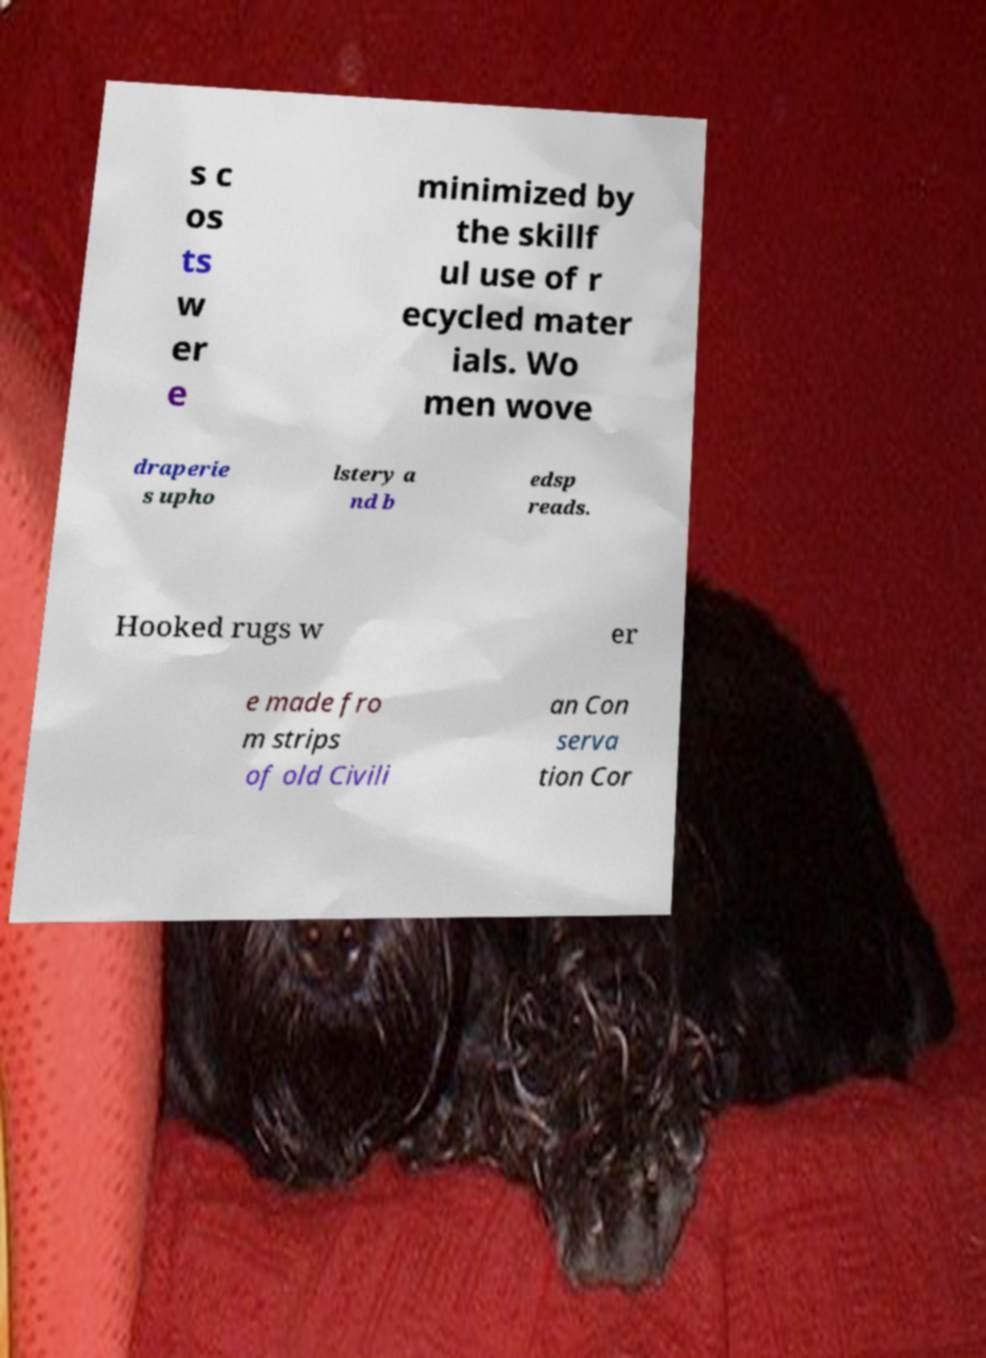For documentation purposes, I need the text within this image transcribed. Could you provide that? s c os ts w er e minimized by the skillf ul use of r ecycled mater ials. Wo men wove draperie s upho lstery a nd b edsp reads. Hooked rugs w er e made fro m strips of old Civili an Con serva tion Cor 